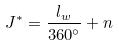<formula> <loc_0><loc_0><loc_500><loc_500>J ^ { * } = \frac { l _ { w } } { 3 6 0 ^ { \circ } } + n</formula> 